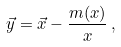<formula> <loc_0><loc_0><loc_500><loc_500>\vec { y } = \vec { x } - \frac { m ( x ) } { x } \, ,</formula> 